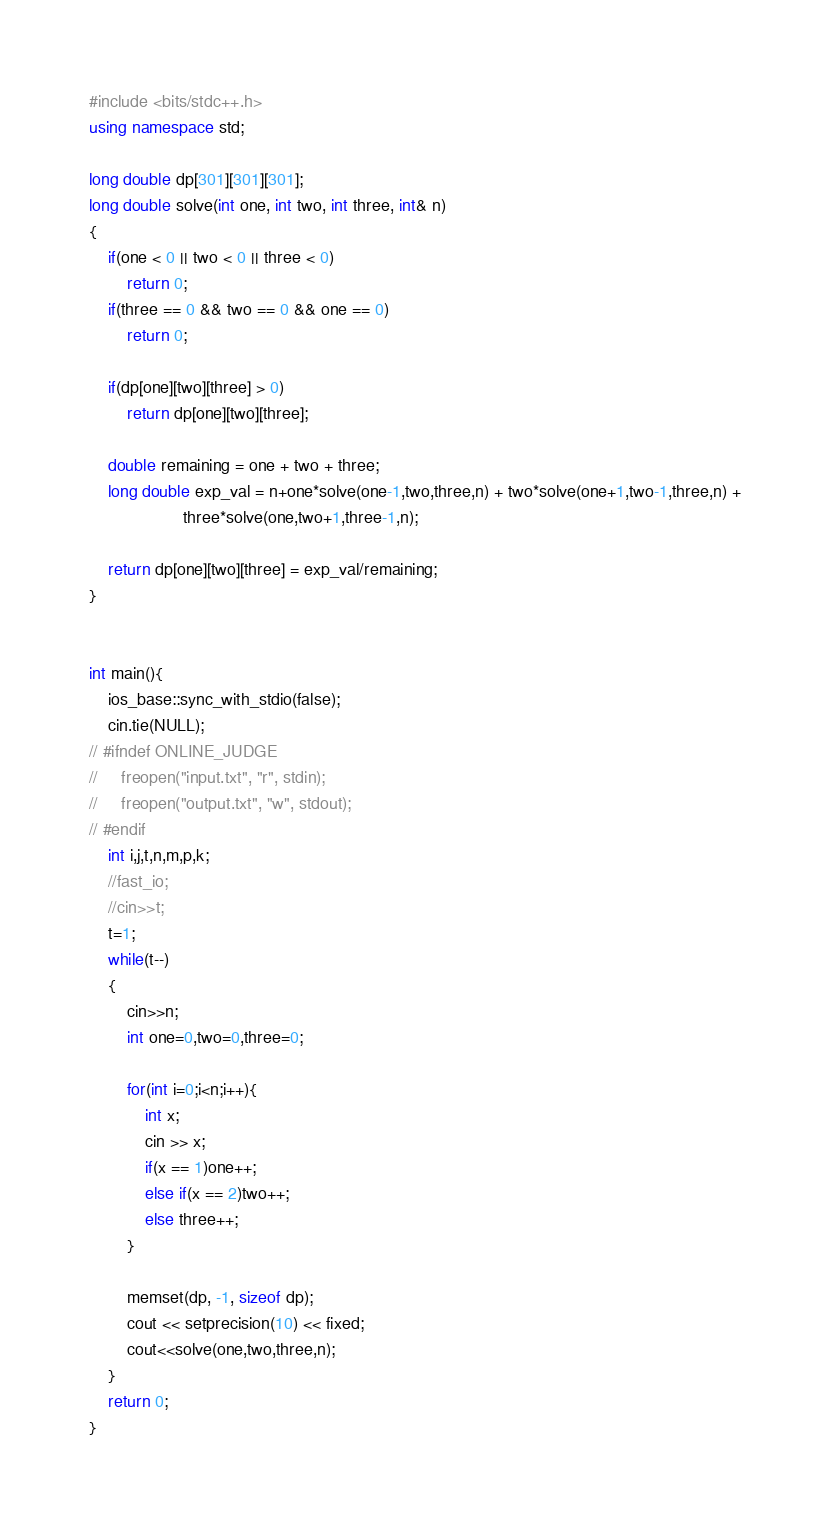Convert code to text. <code><loc_0><loc_0><loc_500><loc_500><_C++_>#include <bits/stdc++.h>
using namespace std;

long double dp[301][301][301];
long double solve(int one, int two, int three, int& n)
{
    if(one < 0 || two < 0 || three < 0)
        return 0;
    if(three == 0 && two == 0 && one == 0)
        return 0;
 
    if(dp[one][two][three] > 0)
        return dp[one][two][three];
 
    double remaining = one + two + three;
    long double exp_val = n+one*solve(one-1,two,three,n) + two*solve(one+1,two-1,three,n) +
                    three*solve(one,two+1,three-1,n);
 
    return dp[one][two][three] = exp_val/remaining;
}
 

int main(){
	ios_base::sync_with_stdio(false); 
    cin.tie(NULL); 
// #ifndef ONLINE_JUDGE 
//     freopen("input.txt", "r", stdin); 
//     freopen("output.txt", "w", stdout); 
// #endif
    int i,j,t,n,m,p,k;
    //fast_io;
    //cin>>t;
    t=1;
    while(t--)
    {
        cin>>n;
        int one=0,two=0,three=0;
 
        for(int i=0;i<n;i++){
            int x;
            cin >> x;
            if(x == 1)one++;
            else if(x == 2)two++;
            else three++;
        }
 
        memset(dp, -1, sizeof dp);
        cout << setprecision(10) << fixed;
        cout<<solve(one,two,three,n);
    }
    return 0;
}</code> 